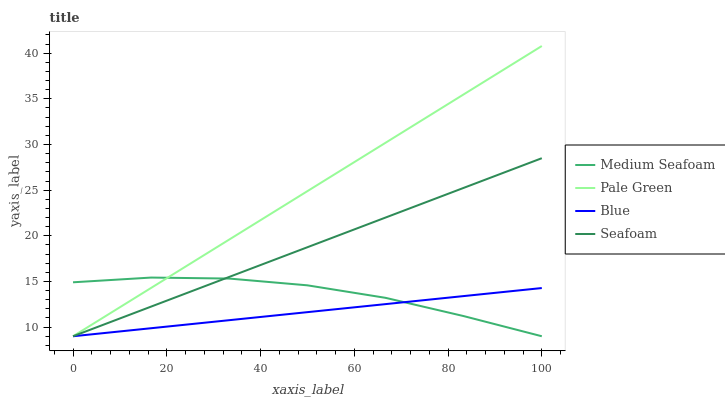Does Blue have the minimum area under the curve?
Answer yes or no. Yes. Does Pale Green have the maximum area under the curve?
Answer yes or no. Yes. Does Medium Seafoam have the minimum area under the curve?
Answer yes or no. No. Does Medium Seafoam have the maximum area under the curve?
Answer yes or no. No. Is Blue the smoothest?
Answer yes or no. Yes. Is Medium Seafoam the roughest?
Answer yes or no. Yes. Is Pale Green the smoothest?
Answer yes or no. No. Is Pale Green the roughest?
Answer yes or no. No. Does Blue have the lowest value?
Answer yes or no. Yes. Does Pale Green have the highest value?
Answer yes or no. Yes. Does Medium Seafoam have the highest value?
Answer yes or no. No. Does Medium Seafoam intersect Seafoam?
Answer yes or no. Yes. Is Medium Seafoam less than Seafoam?
Answer yes or no. No. Is Medium Seafoam greater than Seafoam?
Answer yes or no. No. 